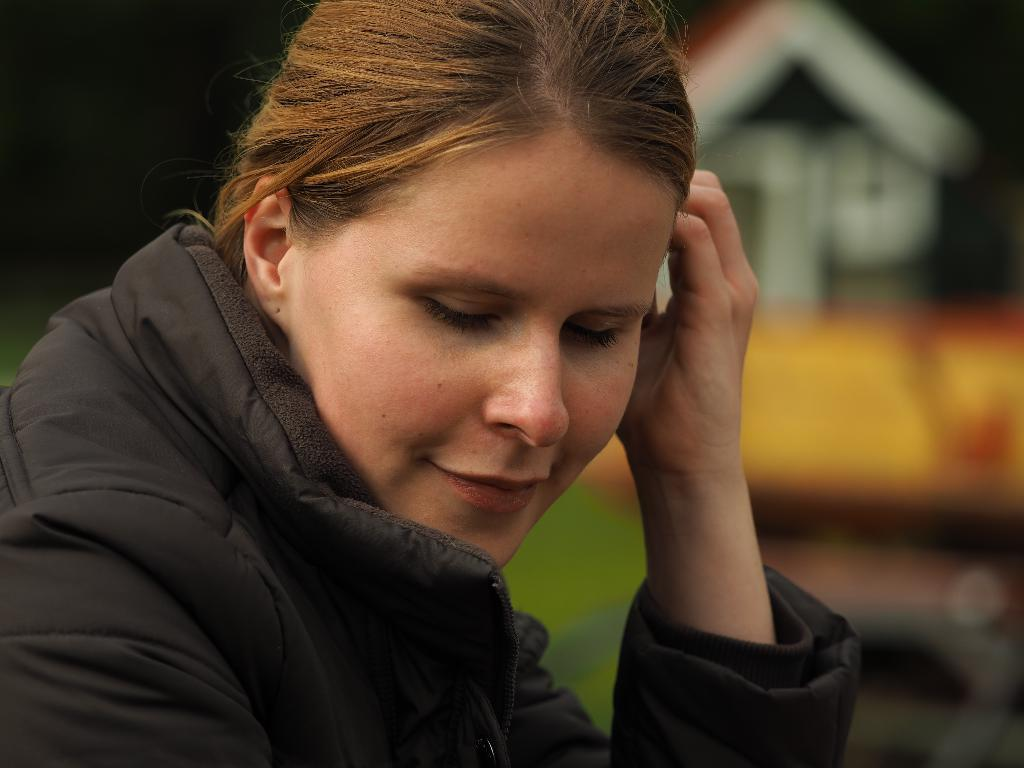Who is the main subject in the image? There is a woman in the image. Can you describe the woman's appearance? The woman has golden hair and is wearing a black jacket. What can be seen in the background of the image? There appears to be a home in the background of the image. Where is the home located in the image? The home is on the right side of the image. What type of adjustment does the woman's brother need to make in the image? There is no mention of a brother in the image, so it is not possible to determine if any adjustments are needed. 